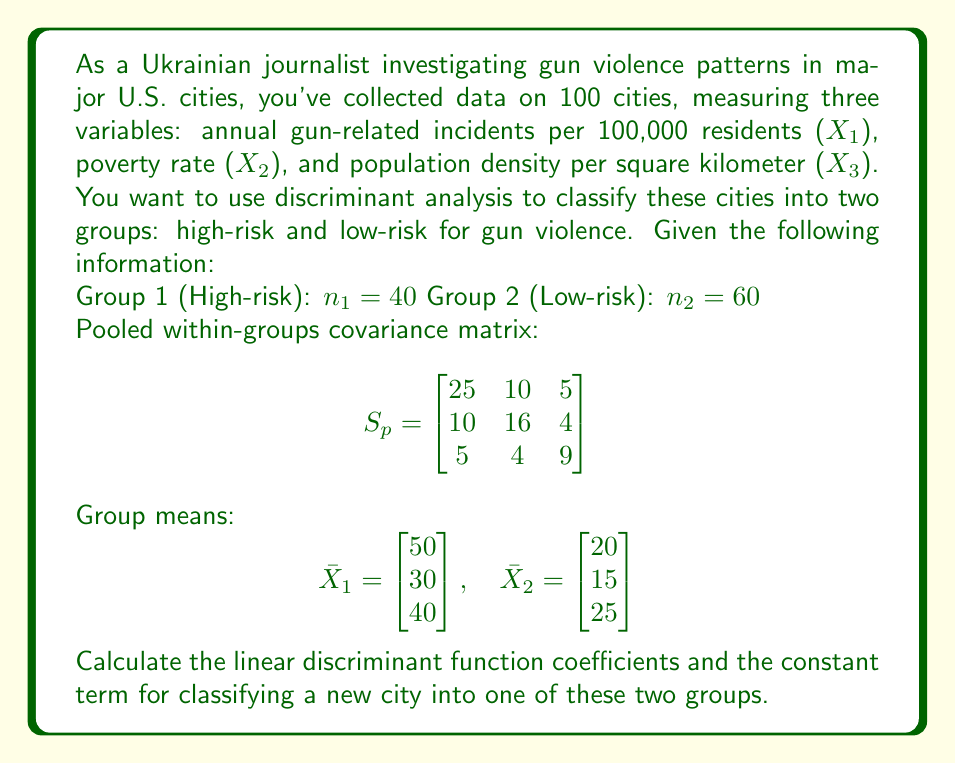Can you solve this math problem? To solve this problem, we'll follow these steps:

1. Calculate the difference between group means:
   $$\bar{X}_1 - \bar{X}_2 = \begin{bmatrix} 50 \\ 30 \\ 40 \end{bmatrix} - \begin{bmatrix} 20 \\ 15 \\ 25 \end{bmatrix} = \begin{bmatrix} 30 \\ 15 \\ 15 \end{bmatrix}$$

2. Calculate the linear discriminant function coefficients:
   $$a = S_p^{-1}(\bar{X}_1 - \bar{X}_2)$$

   First, we need to find $S_p^{-1}$:
   $$S_p^{-1} = \begin{bmatrix}
   0.0514 & -0.0305 & -0.0229 \\
   -0.0305 & 0.0763 & -0.0153 \\
   -0.0229 & -0.0153 & 0.1221
   \end{bmatrix}$$

   Now, we can calculate $a$:
   $$a = \begin{bmatrix}
   0.0514 & -0.0305 & -0.0229 \\
   -0.0305 & 0.0763 & -0.0153 \\
   -0.0229 & -0.0153 & 0.1221
   \end{bmatrix} \begin{bmatrix} 30 \\ 15 \\ 15 \end{bmatrix}$$

   $$a = \begin{bmatrix} 1.0605 \\ 0.6450 \\ 0.9915 \end{bmatrix}$$

3. Calculate the constant term:
   $$c = -\frac{1}{2}a'(\bar{X}_1 + \bar{X}_2) + \ln(\frac{p_1}{p_2})$$

   Where $p_1 = \frac{n_1}{n_1+n_2} = \frac{40}{100} = 0.4$ and $p_2 = \frac{n_2}{n_1+n_2} = \frac{60}{100} = 0.6$

   $$c = -\frac{1}{2}[1.0605, 0.6450, 0.9915] \begin{bmatrix} 70 \\ 45 \\ 65 \end{bmatrix} + \ln(\frac{0.4}{0.6})$$

   $$c = -\frac{1}{2}(74.235 + 29.025 + 64.4475) + \ln(0.6667)$$

   $$c = -83.85375 - 0.40547 = -84.25922$$

The linear discriminant function is:
$$D = 1.0605X_1 + 0.6450X_2 + 0.9915X_3 - 84.25922$$

To classify a new city, calculate D using its values for $X_1$, $X_2$, and $X_3$. If D > 0, classify as high-risk (Group 1); if D < 0, classify as low-risk (Group 2).
Answer: Linear discriminant function coefficients:
$a_1 = 1.0605$
$a_2 = 0.6450$
$a_3 = 0.9915$

Constant term:
$c = -84.25922$

Linear discriminant function:
$$D = 1.0605X_1 + 0.6450X_2 + 0.9915X_3 - 84.25922$$ 